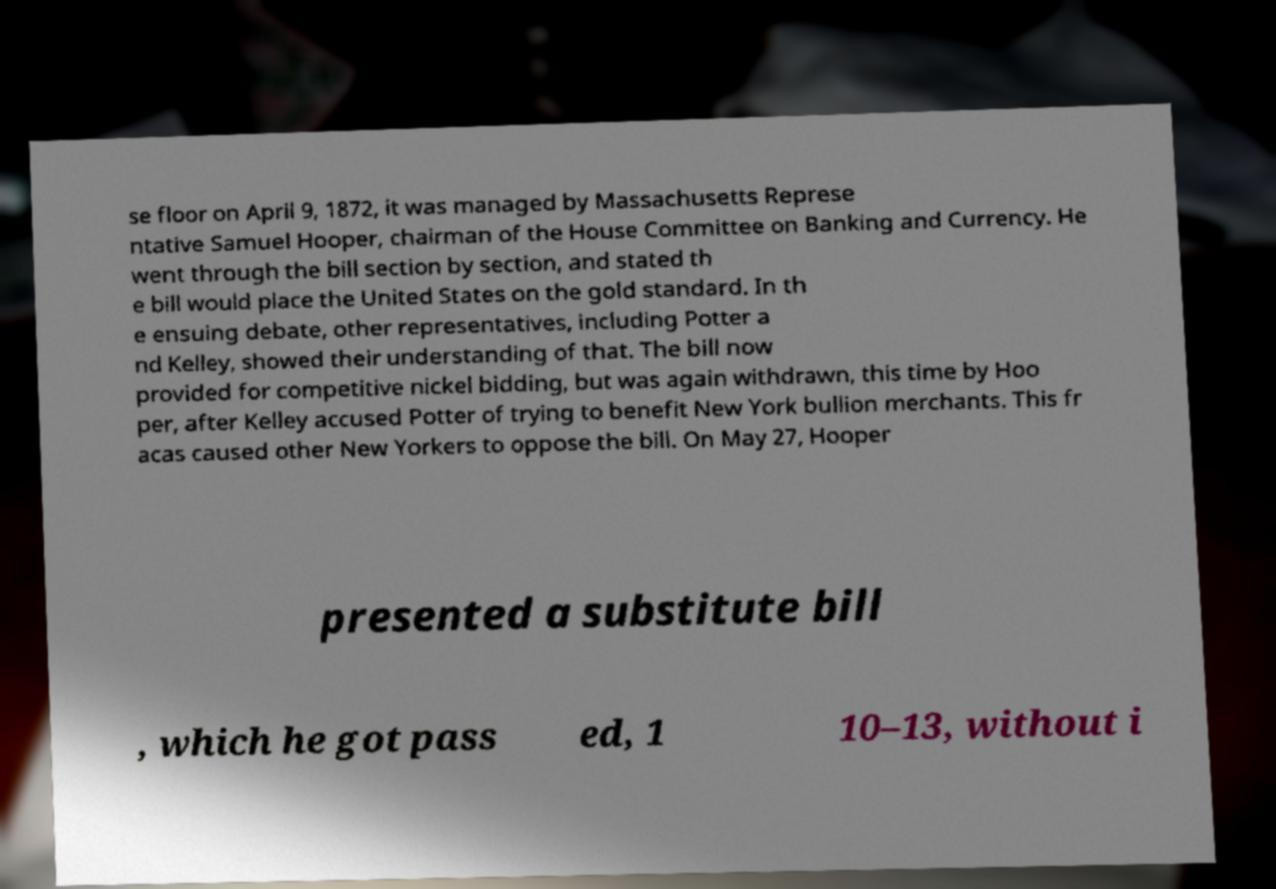Could you assist in decoding the text presented in this image and type it out clearly? se floor on April 9, 1872, it was managed by Massachusetts Represe ntative Samuel Hooper, chairman of the House Committee on Banking and Currency. He went through the bill section by section, and stated th e bill would place the United States on the gold standard. In th e ensuing debate, other representatives, including Potter a nd Kelley, showed their understanding of that. The bill now provided for competitive nickel bidding, but was again withdrawn, this time by Hoo per, after Kelley accused Potter of trying to benefit New York bullion merchants. This fr acas caused other New Yorkers to oppose the bill. On May 27, Hooper presented a substitute bill , which he got pass ed, 1 10–13, without i 